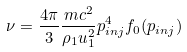Convert formula to latex. <formula><loc_0><loc_0><loc_500><loc_500>\nu = \frac { 4 \pi } { 3 } \frac { m c ^ { 2 } } { \rho _ { 1 } u ^ { 2 } _ { 1 } } p _ { i n j } ^ { 4 } f _ { 0 } ( p _ { i n j } )</formula> 